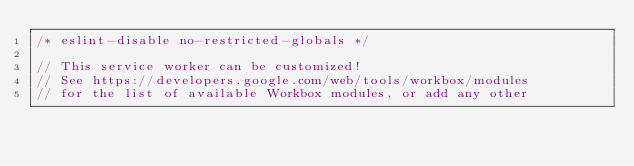Convert code to text. <code><loc_0><loc_0><loc_500><loc_500><_JavaScript_>/* eslint-disable no-restricted-globals */

// This service worker can be customized!
// See https://developers.google.com/web/tools/workbox/modules
// for the list of available Workbox modules, or add any other</code> 